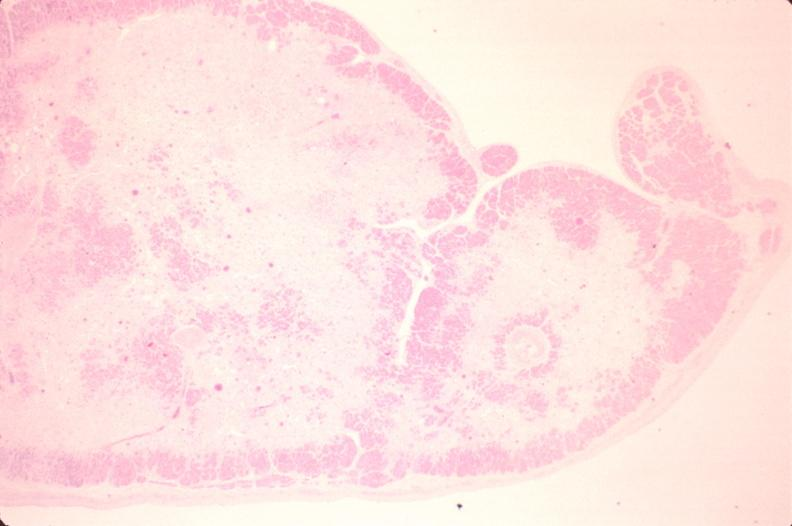s leiomyosarcoma present?
Answer the question using a single word or phrase. No 